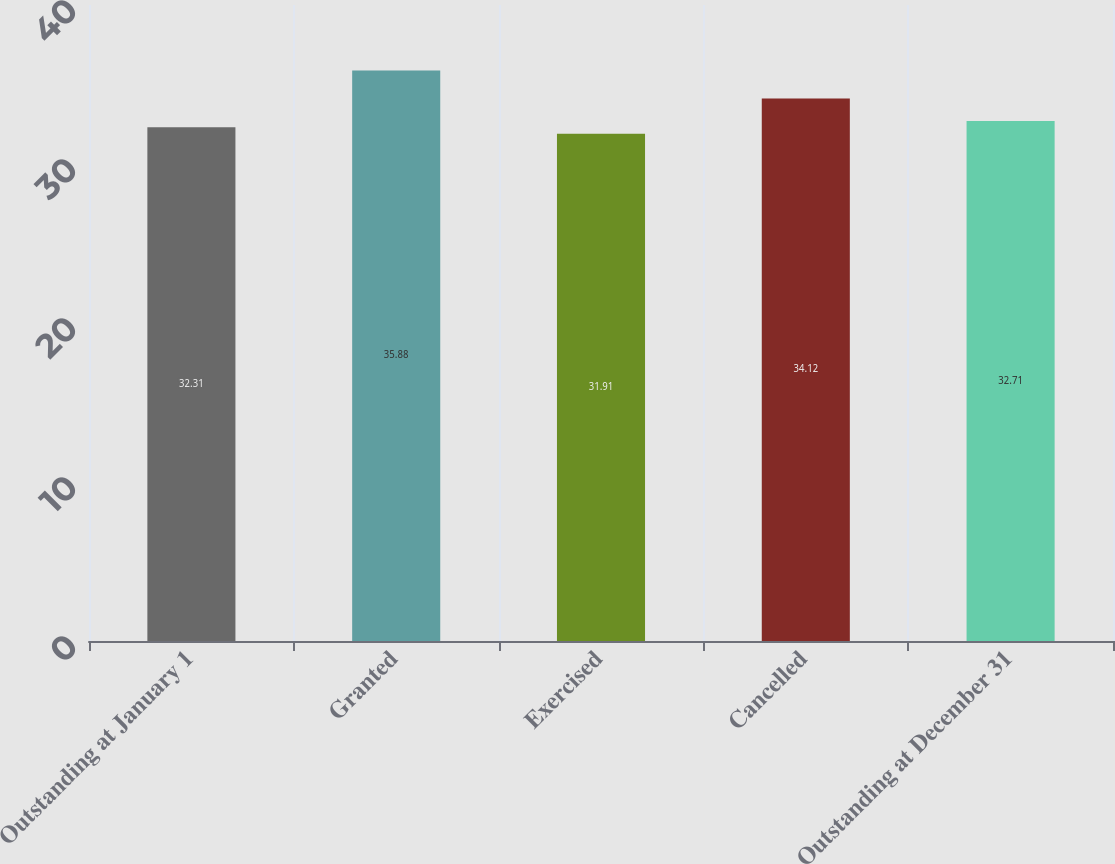<chart> <loc_0><loc_0><loc_500><loc_500><bar_chart><fcel>Outstanding at January 1<fcel>Granted<fcel>Exercised<fcel>Cancelled<fcel>Outstanding at December 31<nl><fcel>32.31<fcel>35.88<fcel>31.91<fcel>34.12<fcel>32.71<nl></chart> 